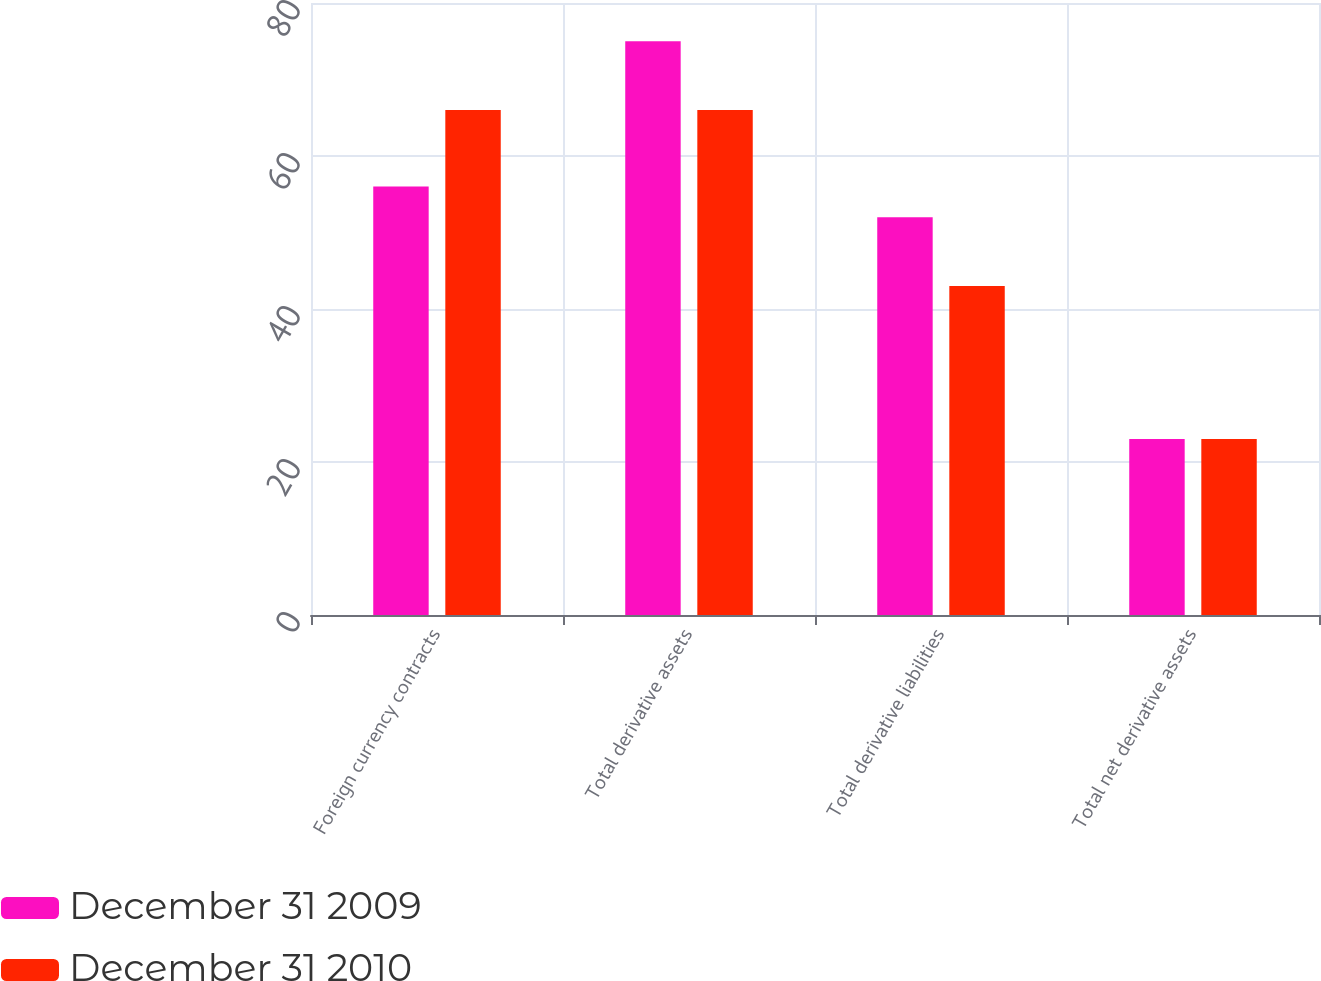Convert chart. <chart><loc_0><loc_0><loc_500><loc_500><stacked_bar_chart><ecel><fcel>Foreign currency contracts<fcel>Total derivative assets<fcel>Total derivative liabilities<fcel>Total net derivative assets<nl><fcel>December 31 2009<fcel>56<fcel>75<fcel>52<fcel>23<nl><fcel>December 31 2010<fcel>66<fcel>66<fcel>43<fcel>23<nl></chart> 